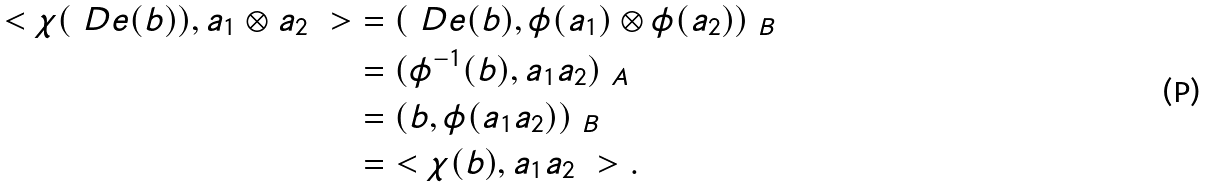Convert formula to latex. <formula><loc_0><loc_0><loc_500><loc_500>\ < \chi ( \ D e ( b ) ) , a _ { 1 } \otimes a _ { 2 } \ > & = ( \ D e ( b ) , \phi ( a _ { 1 } ) \otimes \phi ( a _ { 2 } ) ) _ { \ B } \\ & = ( \phi ^ { - 1 } ( b ) , a _ { 1 } a _ { 2 } ) _ { \ A } \\ & = ( b , \phi ( a _ { 1 } a _ { 2 } ) ) _ { \ B } \\ & = \ < \chi ( b ) , a _ { 1 } a _ { 2 } \ > .</formula> 